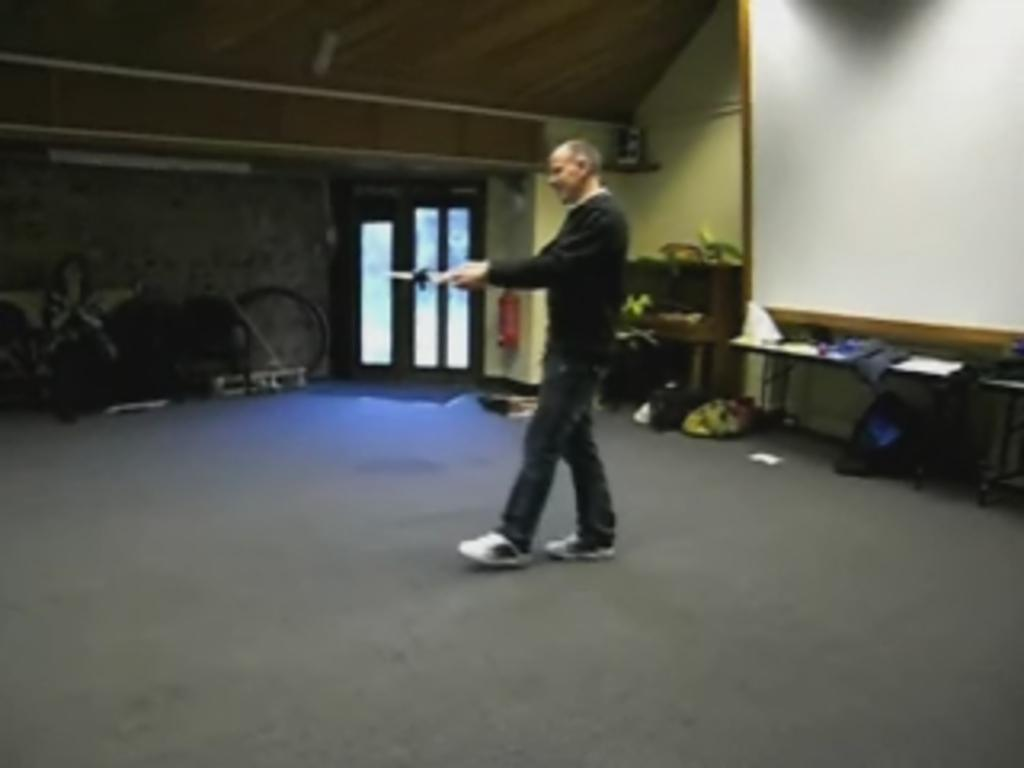What is the man in the image doing? The man is standing in the image. What is the man holding in the image? The man is holding an object. What can be seen in the background of the image? There is a white color board and a table in the background of the image. Are there any other objects visible in the background? Yes, there are some objects in the background of the image. What type of print can be seen on the ground in the image? There is no print on the ground in the image, as the ground is not visible. --- Facts: 1. There is a group of people in the image. 2. The people are wearing hats. 3. There is a sign in the image. 4. The sign has letters on it. 5. The background of the image is a cityscape. Absurd Topics: ocean, parrot, dance Conversation: How many people are in the image? There is a group of people in the image. What are the people wearing in the image? The people are wearing hats in the image. What can be seen in the image besides the people? There is a sign in the image, and the background of the image is a cityscape. What information is provided on the sign? The sign has letters on it, which may convey information or a message. Reasoning: Let's think step by step in order to produce the conversation. We start by identifying the main subject in the image, which is the group of people. Then, we describe the people's attire, noting that they are wearing hats. Next, we mention the presence of the sign and its letters, which may provide additional context or information. Finally, we describe the background of the image, which is a cityscape. Absurd Question/Answer: Can you see any parrots dancing in the ocean in the image? There are no parrots or ocean present in the image; it features a group of people wearing hats, a sign with letters, and a cityscape background. 